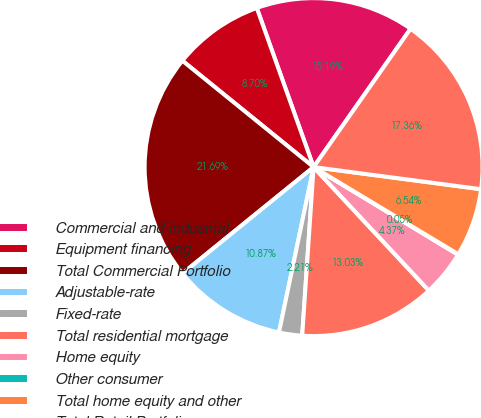<chart> <loc_0><loc_0><loc_500><loc_500><pie_chart><fcel>Commercial and industrial<fcel>Equipment financing<fcel>Total Commercial Portfolio<fcel>Adjustable-rate<fcel>Fixed-rate<fcel>Total residential mortgage<fcel>Home equity<fcel>Other consumer<fcel>Total home equity and other<fcel>Total Retail Portfolio<nl><fcel>15.19%<fcel>8.7%<fcel>21.69%<fcel>10.87%<fcel>2.21%<fcel>13.03%<fcel>4.37%<fcel>0.05%<fcel>6.54%<fcel>17.36%<nl></chart> 